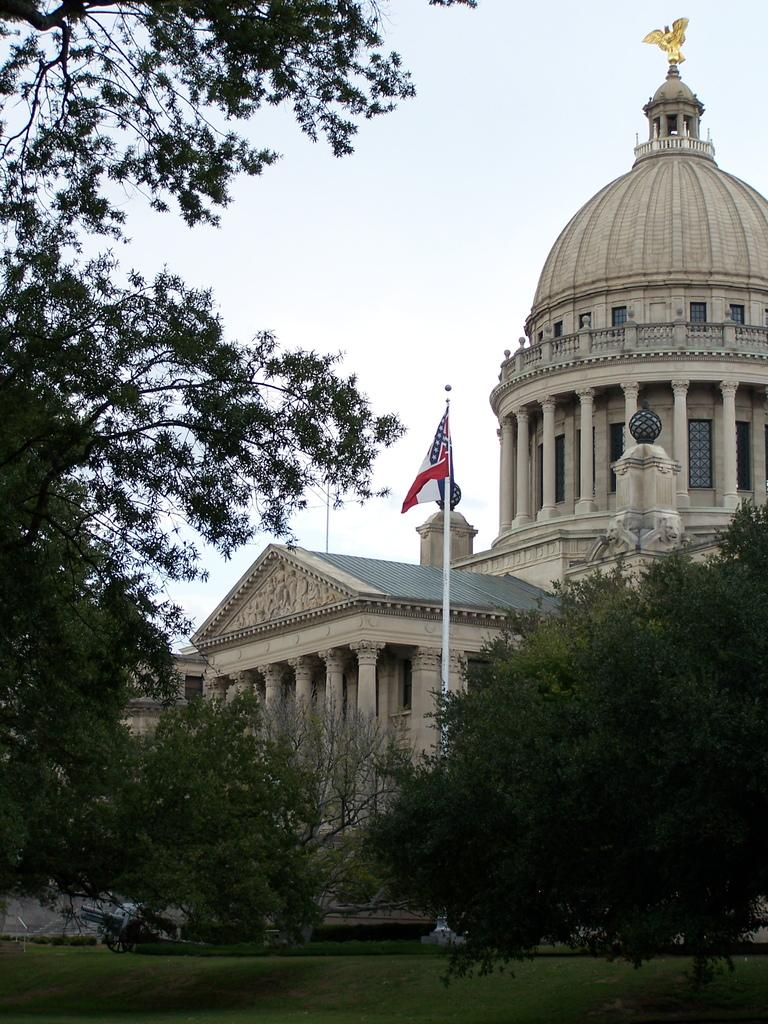What type of vegetation can be seen in the foreground of the image? There is grass, plants, and trees in the foreground of the image. What structure is present in the foreground of the image? There is a flagpole in the foreground of the image. What can be seen in the background of the image? There are buildings, pillars, a statue, and the sky visible in the background of the image. Can you describe the time of day when the image might have been taken? The image might have been taken during the day, as the sky is visible. How does the beginner laborer shake the statue in the image? There is no laborer present in the image, and therefore no shaking of the statue can be observed. What type of shoes does the shake wear in the image? There is no one wearing shoes in the image, as there is no person present. 